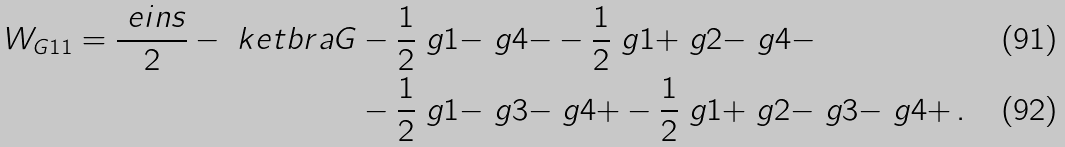Convert formula to latex. <formula><loc_0><loc_0><loc_500><loc_500>W _ { G 1 1 } = \frac { \ e i n s } { 2 } - \ k e t b r a { G } & - \frac { 1 } { 2 } \ g { 1 } { - } \ g { 4 } { - } - \frac { 1 } { 2 } \ g { 1 } { + } \ g { 2 } { - } \ g { 4 } { - } \\ & - \frac { 1 } { 2 } \ g { 1 } { - } \ g { 3 } { - } \ g { 4 } { + } - \frac { 1 } { 2 } \ g { 1 } { + } \ g { 2 } { - } \ g { 3 } { - } \ g { 4 } { + } \, .</formula> 